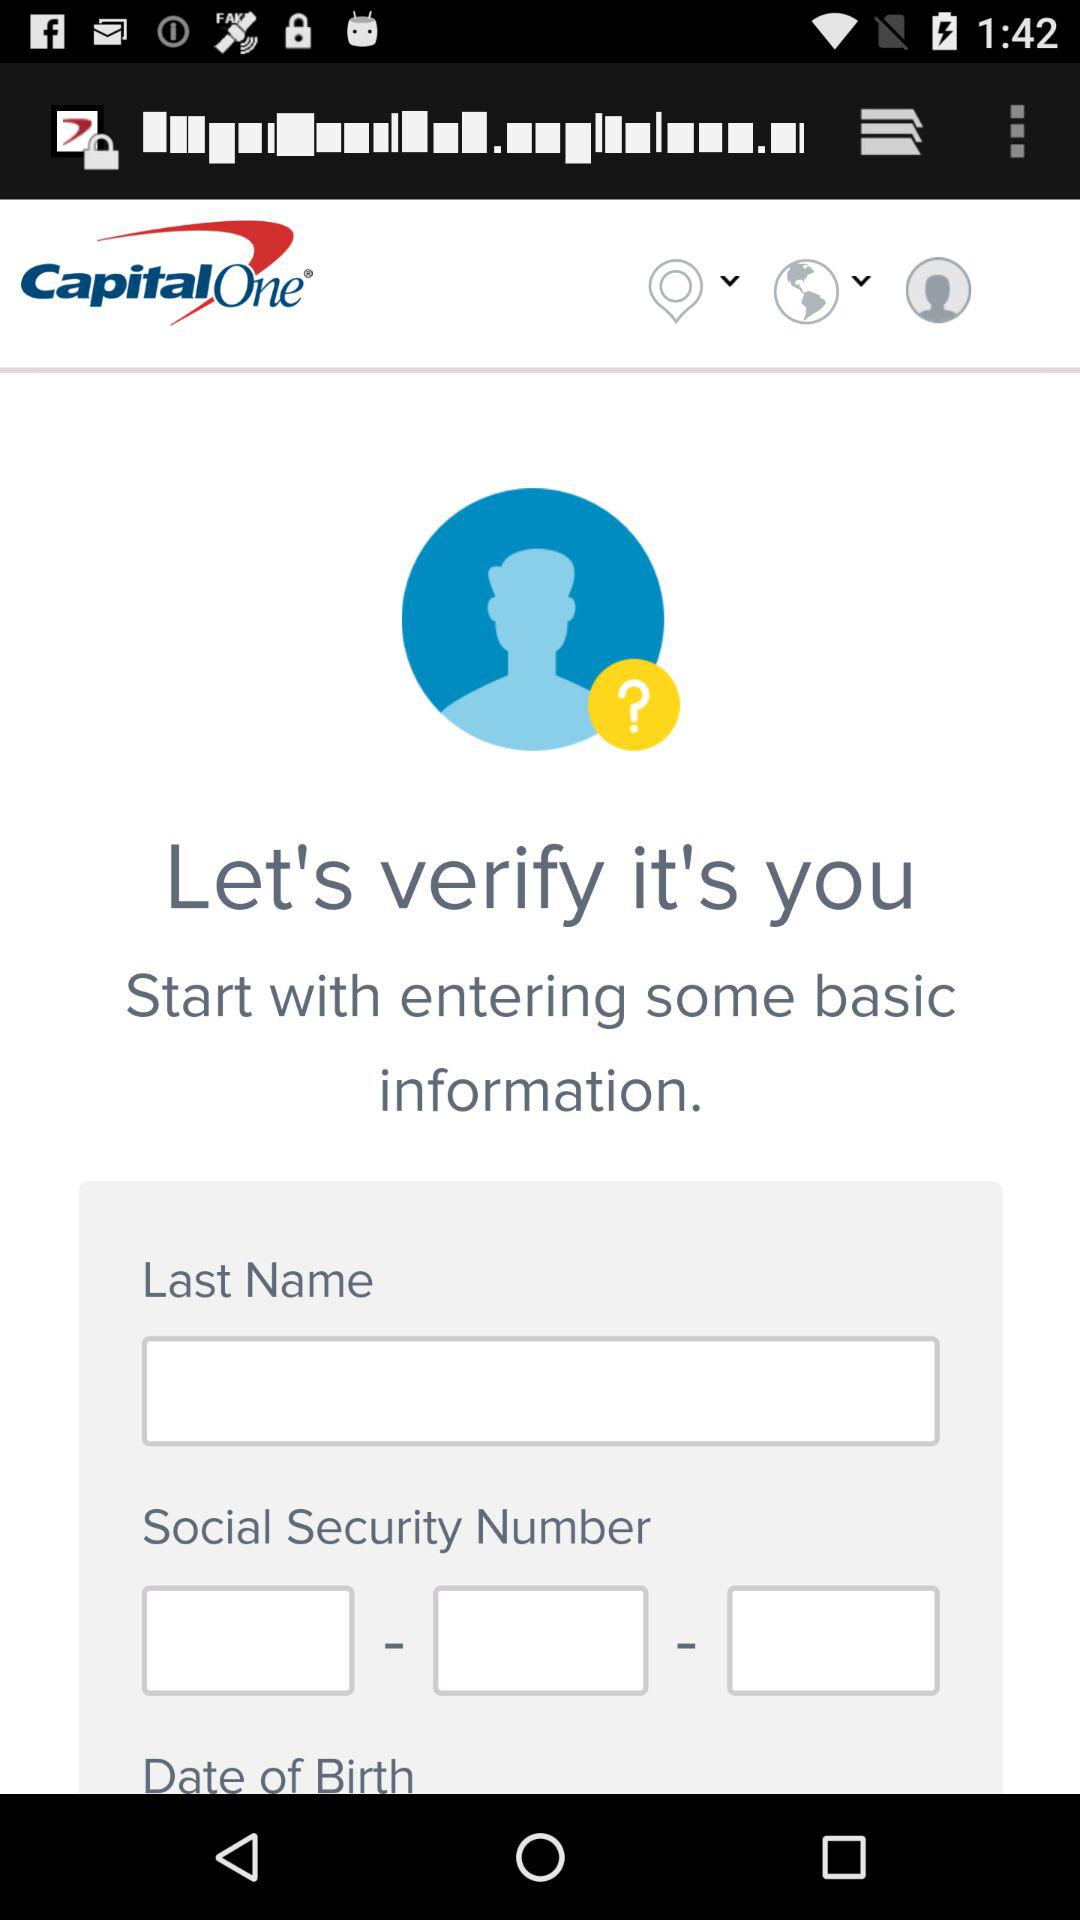What is the user's last name?
When the provided information is insufficient, respond with <no answer>. <no answer> 